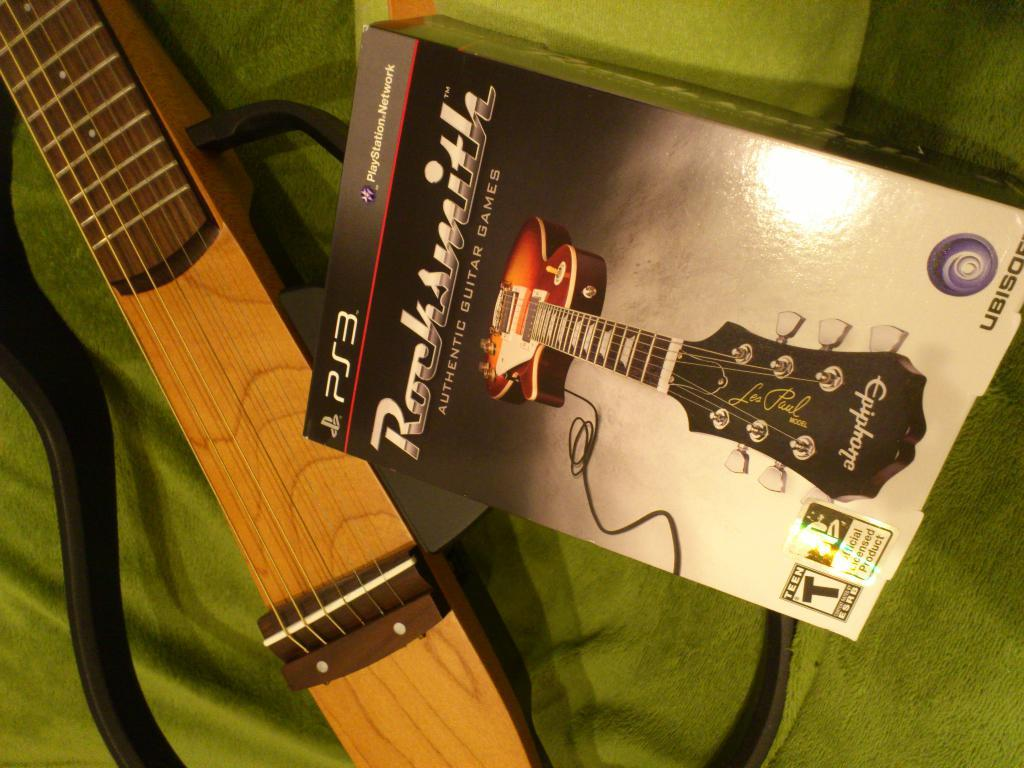What object can be seen in the image that is typically used for storage? There is a box in the image that is typically used for storage. What musical instrument is visible in the image? There is a guitar in the image. Who is the creator of the guitar in the image? The image does not provide information about the guitar's creator, so it cannot be determined from the image. 